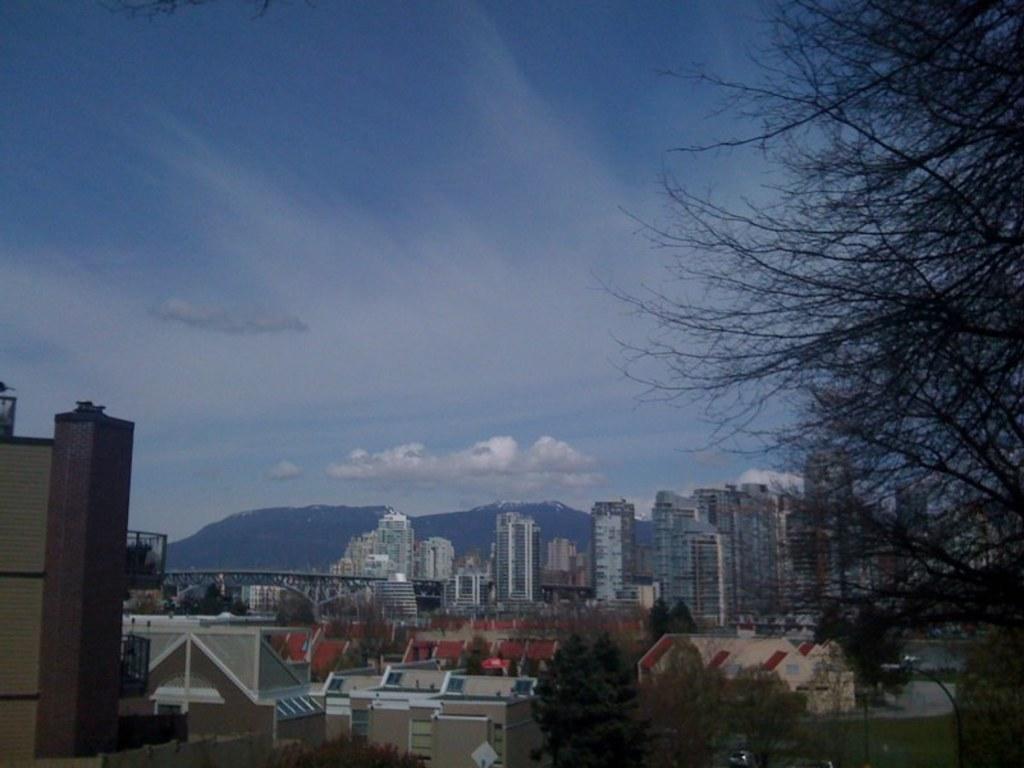In one or two sentences, can you explain what this image depicts? In this image I can see buildings and trees. In the background I can see mountains and the sky. 